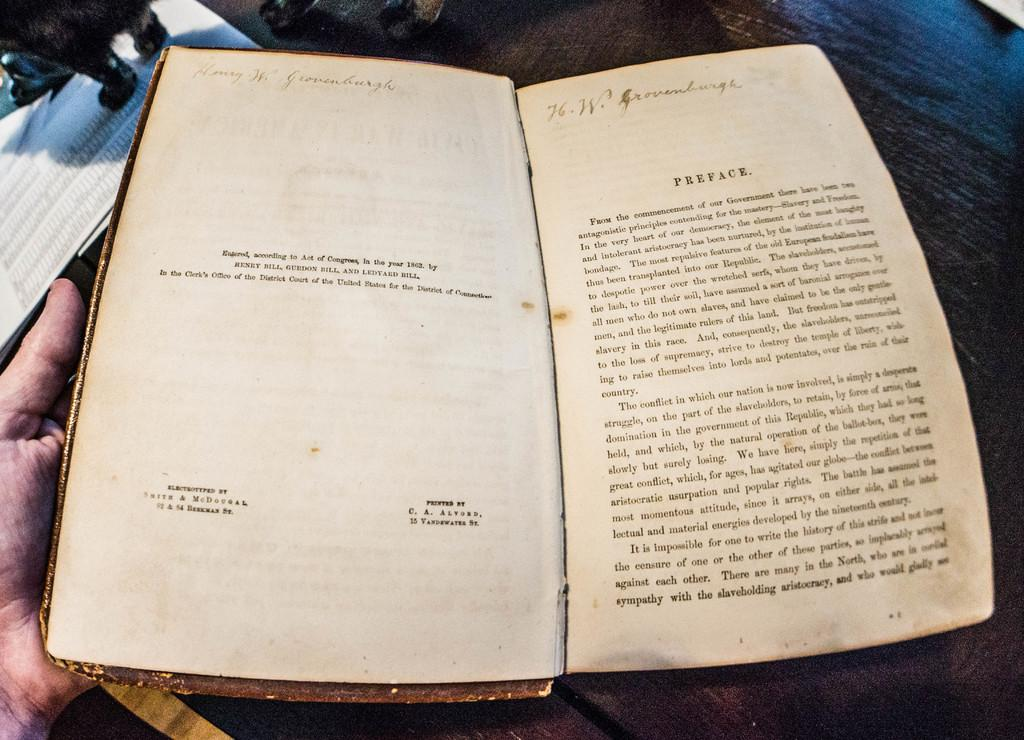<image>
Write a terse but informative summary of the picture. The preface of an old, dirty book by Henry Bill, Gurdon Bill, and Ledyard Bill. 